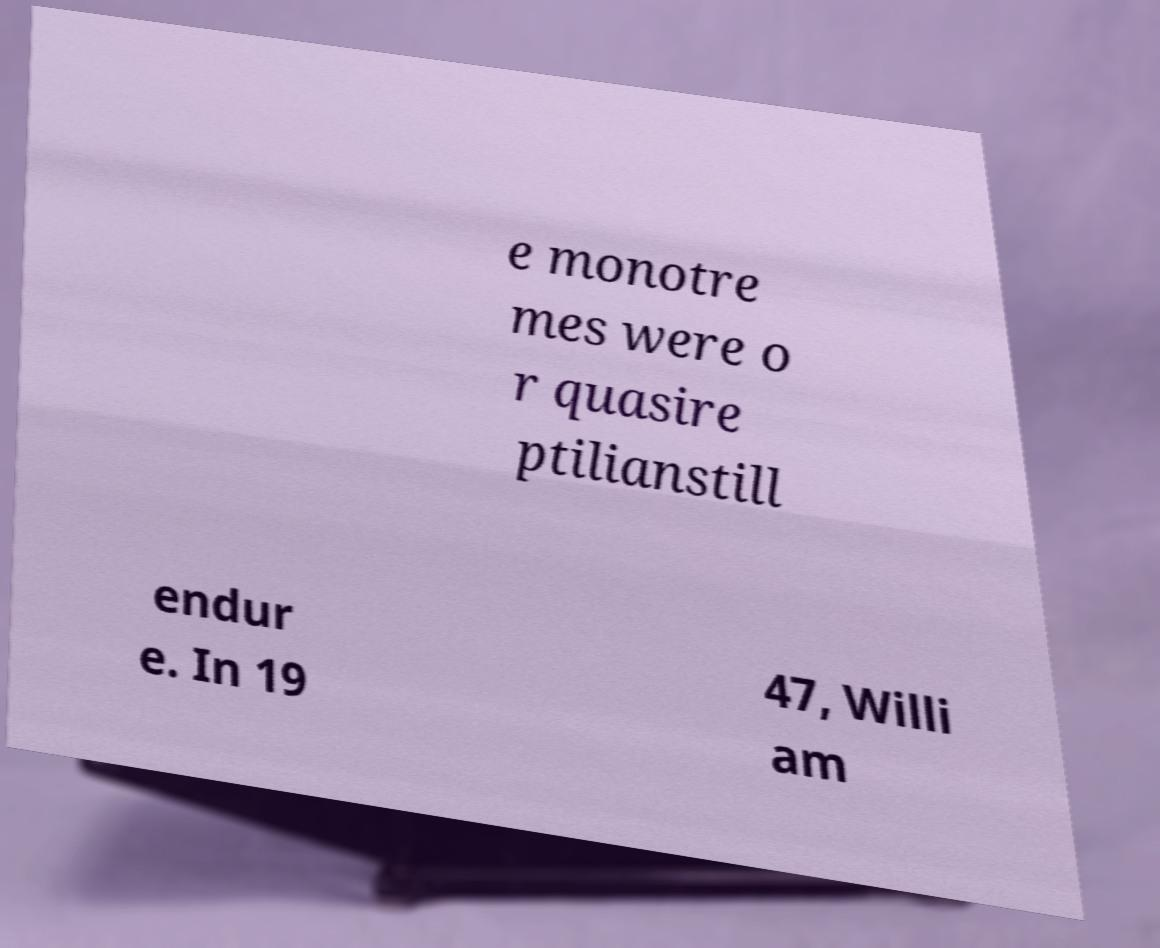For documentation purposes, I need the text within this image transcribed. Could you provide that? e monotre mes were o r quasire ptilianstill endur e. In 19 47, Willi am 